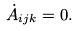Convert formula to latex. <formula><loc_0><loc_0><loc_500><loc_500>\dot { A } _ { i j k } = 0 .</formula> 